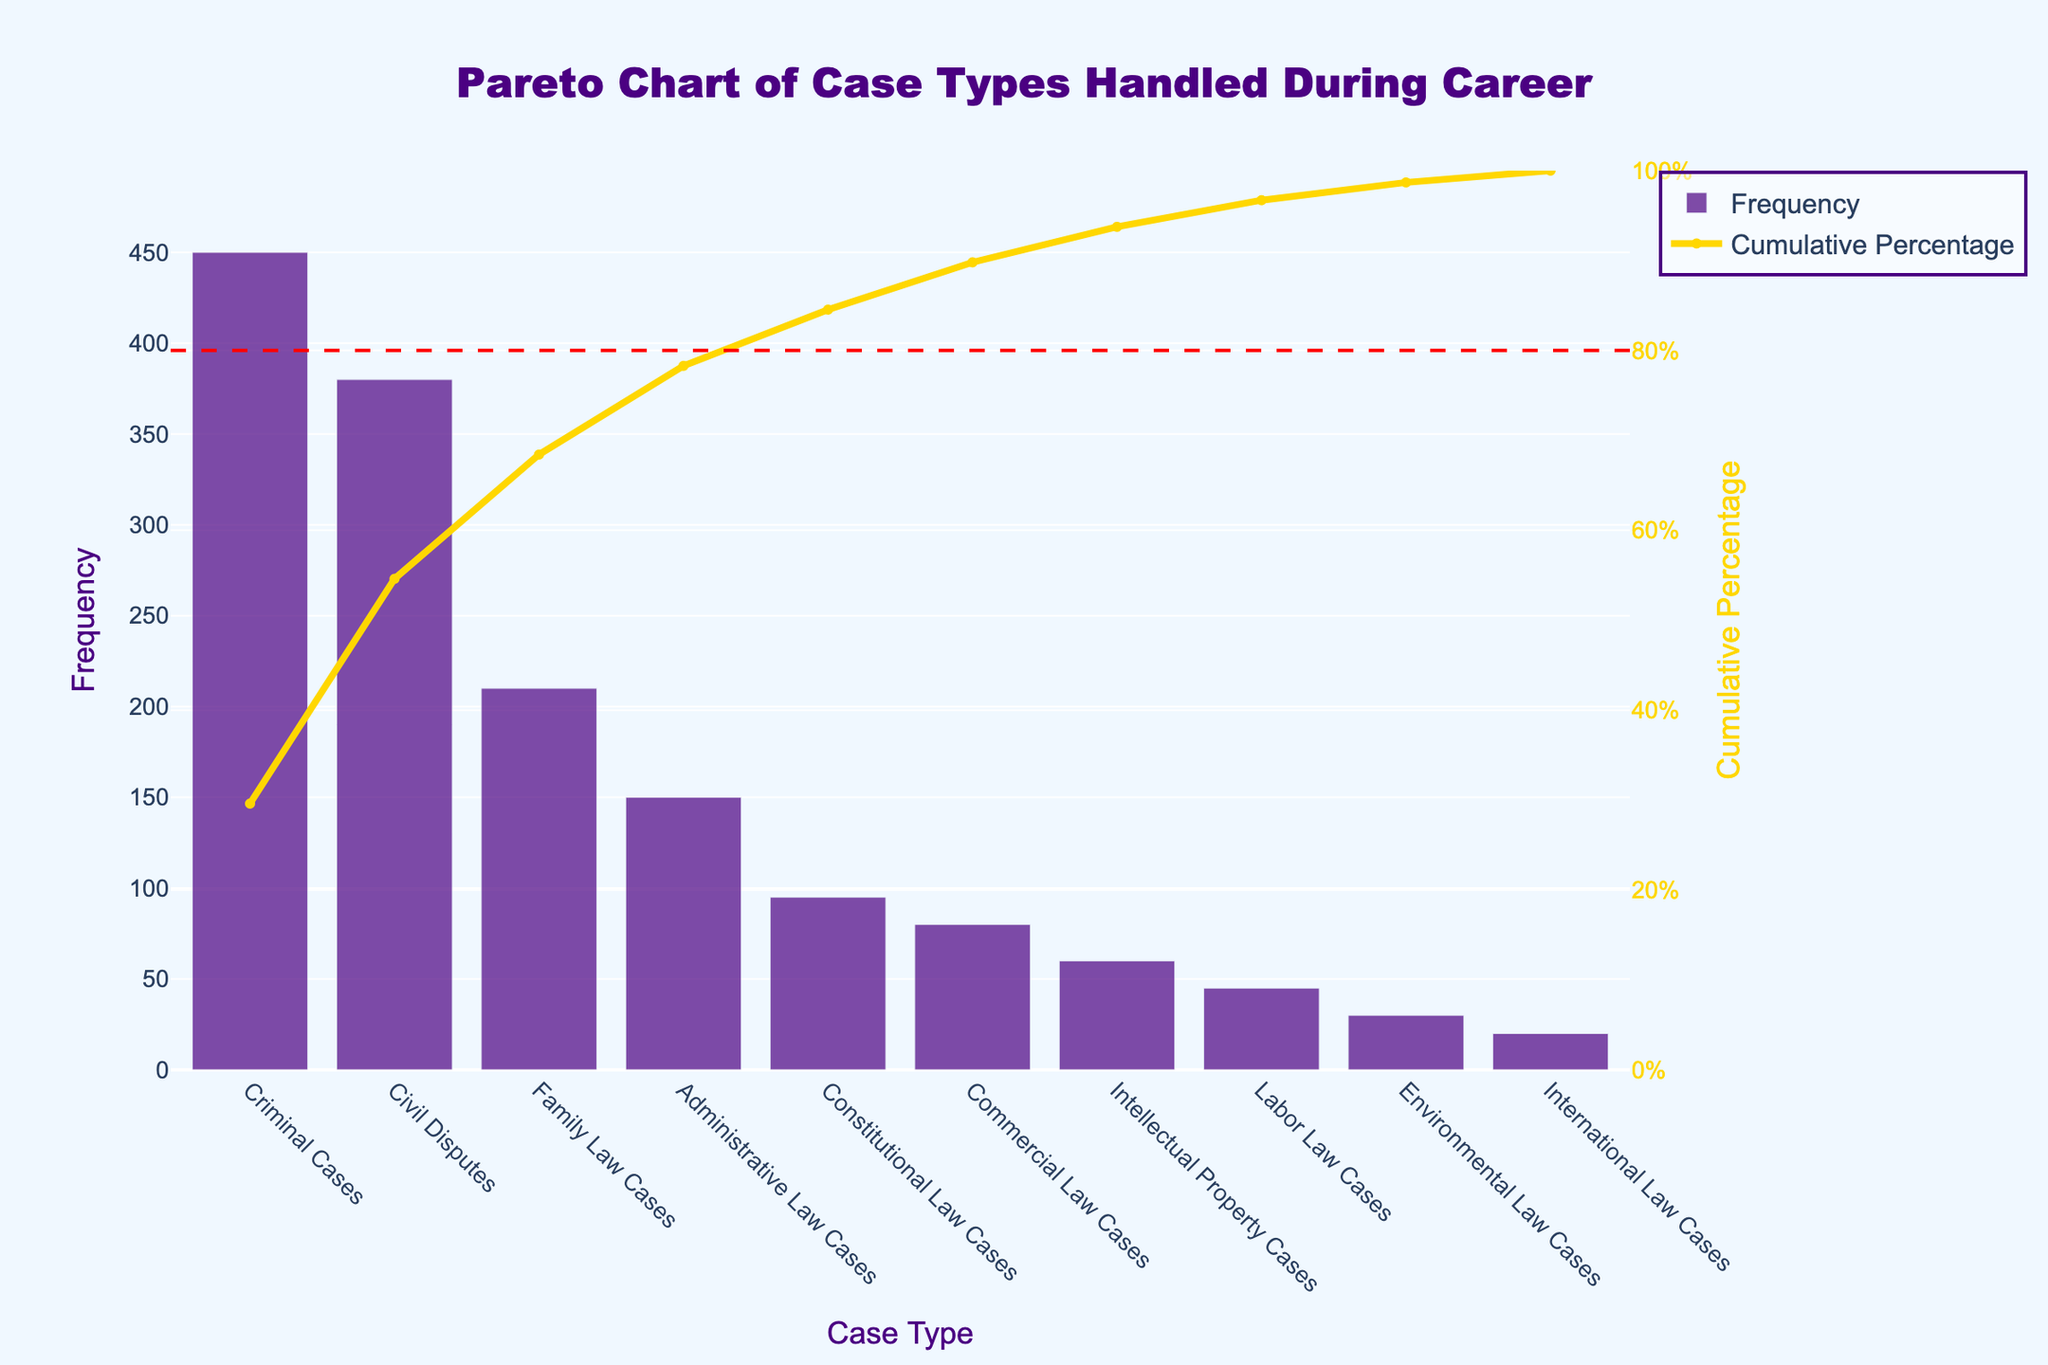What is the title of the Pareto chart? The title is the text displayed at the top of the chart and is usually the most prominent text present.
Answer: Pareto Chart of Case Types Handled During Career Which case type has the highest frequency? The case type with the highest frequency can be identified by looking at the tallest bar on the chart.
Answer: Criminal Cases How many case types have a frequency over 300? Count the number of bars that extend above the 300 mark on the y-axis.
Answer: 2 What is the cumulative percentage for Civil Disputes? Trace the line corresponding to Civil Disputes on the x-axis and find the y-value on the line chart representing the cumulative percentage.
Answer: 60.53% What are the two least frequent case types? Identify the shortest two bars on the bar chart.
Answer: Environmental Law Cases and International Law Cases How does the frequency of Family Law Cases compare to Commercial Law Cases? Compare the heights of the bars corresponding to Family Law Cases and Commercial Law Cases.
Answer: Family Law Cases are more frequent What percentage of total cases is represented by Criminal and Civil Disputes combined? Sum the frequencies of Criminal and Civil Disputes and divide by the total frequency, then multiply by 100. (450 + 380) / 1520 * 100 = 54.6%
Answer: 54.6% What is the function of the red dashed line? The red dashed line is drawn at the 80% mark on the secondary y-axis, indicating the 80-20 rule common in Pareto charts.
Answer: Represents 80% cumulative percentage At which case type does the cumulative percentage first exceed 80%? Find where the cumulative percentage line first crosses the 80% mark on the secondary y-axis.
Answer: Administrative Law Cases What is the difference in frequency between Intellectual Property Cases and Labor Law Cases? Subtract the frequency of Labor Law Cases from the frequency of Intellectual Property Cases. 60 - 45 = 15
Answer: 15 